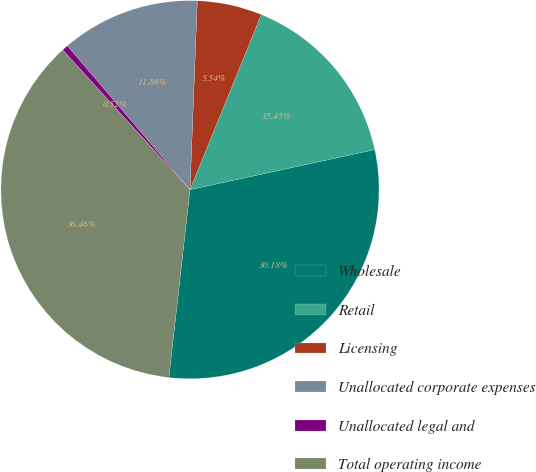<chart> <loc_0><loc_0><loc_500><loc_500><pie_chart><fcel>Wholesale<fcel>Retail<fcel>Licensing<fcel>Unallocated corporate expenses<fcel>Unallocated legal and<fcel>Total operating income<nl><fcel>30.18%<fcel>15.45%<fcel>5.54%<fcel>11.86%<fcel>0.52%<fcel>36.46%<nl></chart> 